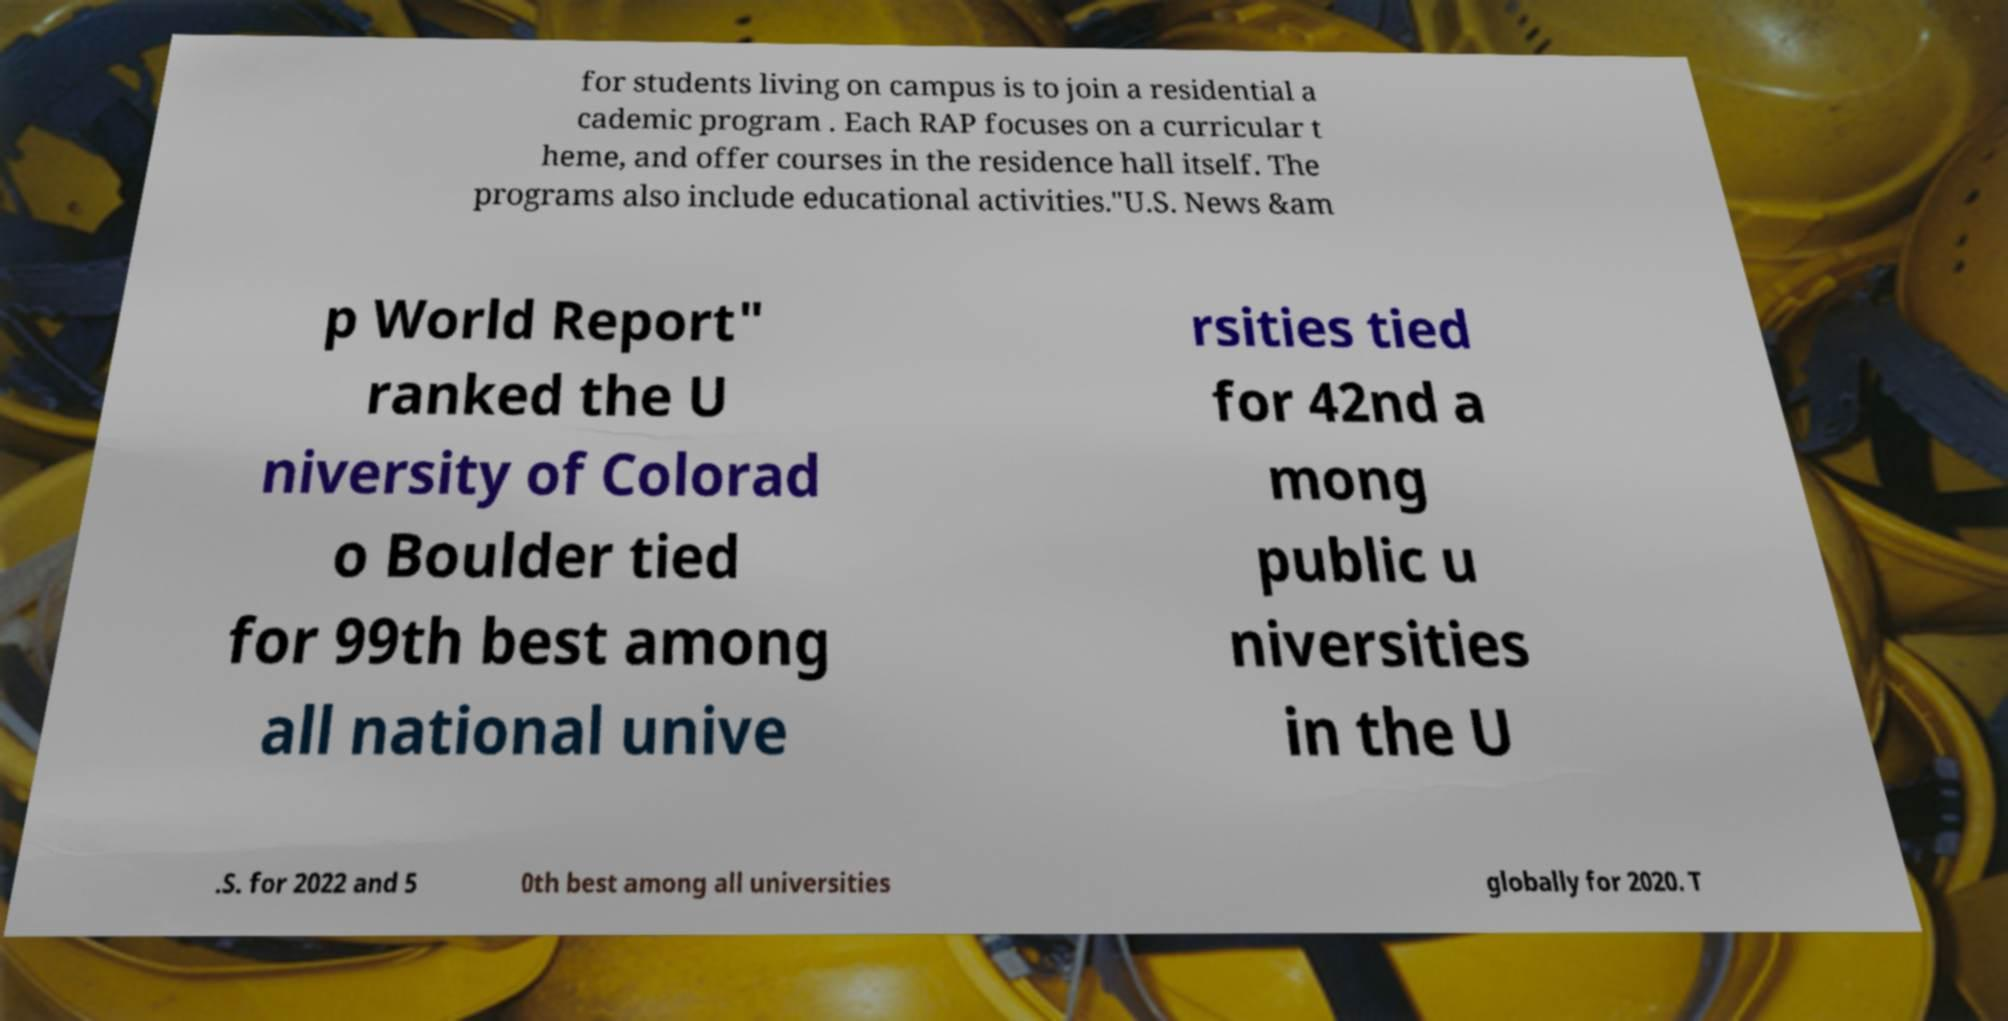Please identify and transcribe the text found in this image. for students living on campus is to join a residential a cademic program . Each RAP focuses on a curricular t heme, and offer courses in the residence hall itself. The programs also include educational activities."U.S. News &am p World Report" ranked the U niversity of Colorad o Boulder tied for 99th best among all national unive rsities tied for 42nd a mong public u niversities in the U .S. for 2022 and 5 0th best among all universities globally for 2020. T 